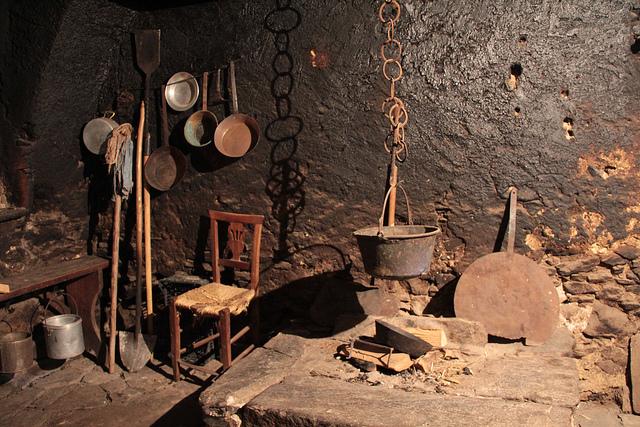How many pins are on the wall?
Concise answer only. 5. Why is the tin all rusted?
Short answer required. Old. Is it dirty or clean?
Answer briefly. Dirty. 